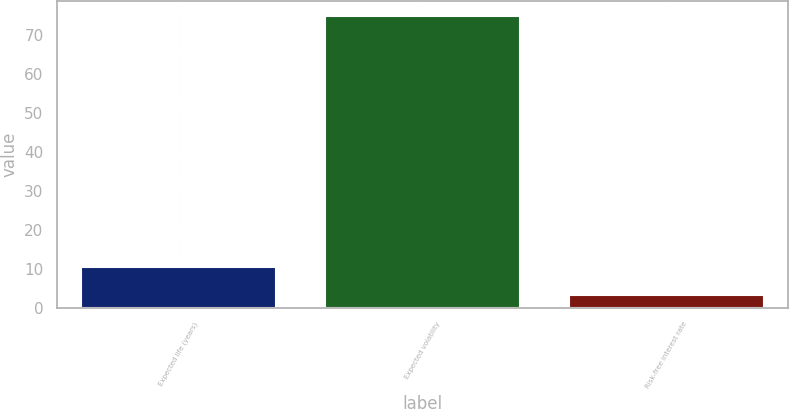<chart> <loc_0><loc_0><loc_500><loc_500><bar_chart><fcel>Expected life (years)<fcel>Expected volatility<fcel>Risk-free interest rate<nl><fcel>10.44<fcel>75<fcel>3.27<nl></chart> 